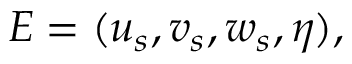Convert formula to latex. <formula><loc_0><loc_0><loc_500><loc_500>E = ( u _ { s } , v _ { s } , w _ { s } , \eta ) ,</formula> 